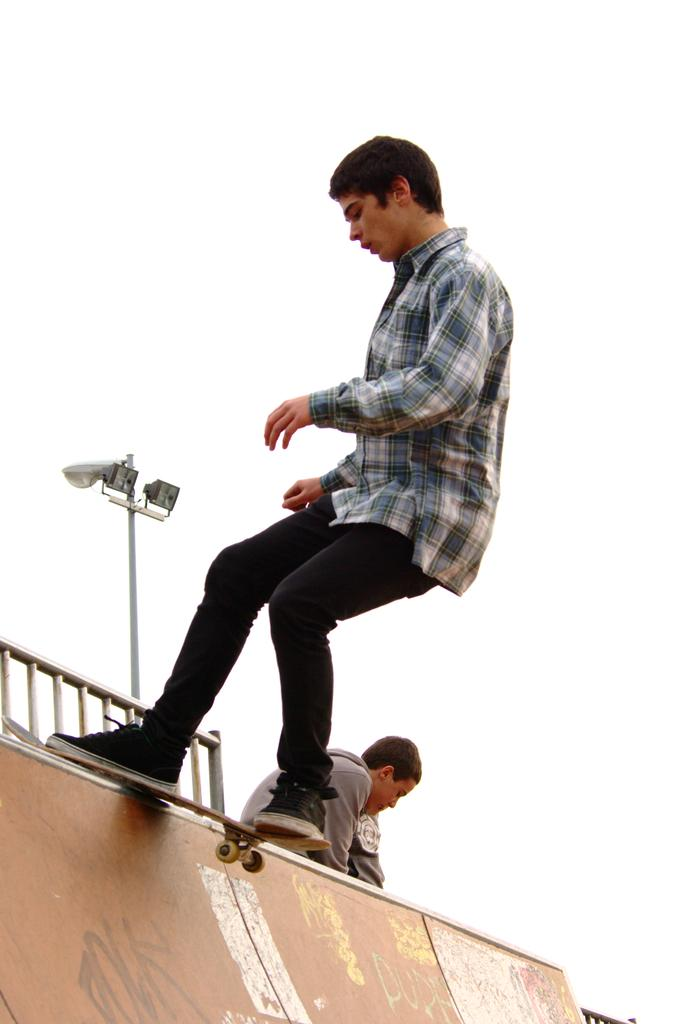What activity is the man in the image engaged in? The man in the image is doing skating. Who else is present in the image? There is a person sitting behind the skating man. What can be seen in the background of the image? There is a fencing and a pole in the image. What is visible at the top of the image? The sky is visible at the top of the image. What type of vein is visible in the image? There is no vein visible in the image; it features a man doing skating, a person sitting behind him, a fencing, a pole, and the sky. 